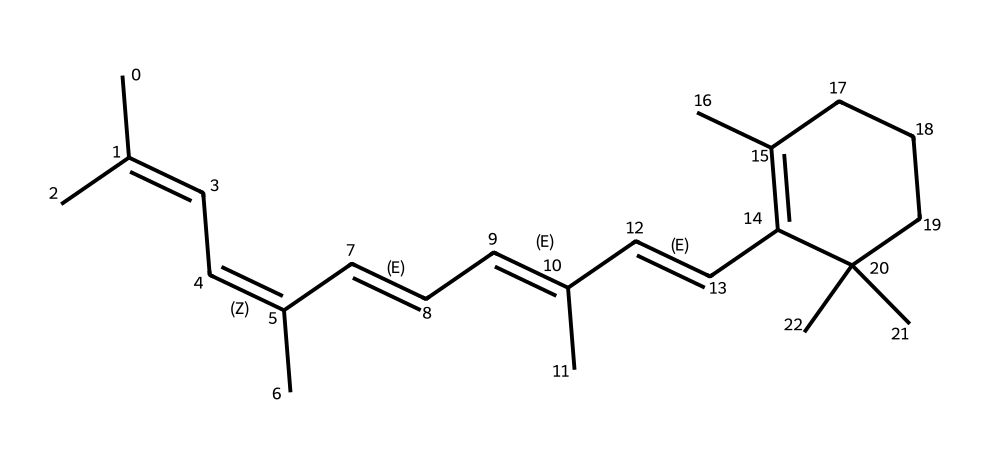how many carbon atoms are in this structure? The chemical structure can be analyzed by counting the carbon atoms in the SMILES representation. Each "C" or "C(" indicates a carbon atom. In this case, there are 20 carbon atoms in total.
Answer: 20 what functional groups are present in retinal? By examining the structure, retinal contains conjugated double bonds (alkene) but does not have any hydroxyl, carboxylic acid, or amine groups. The presence of multiple double bonds is characteristic of aldehydes, as the molecule ends with the -C=O functional group present in its open-chain form. Thus, it is primarily an alkene with an aldehyde functional group.
Answer: alkene, aldehyde is this molecule a geometric isomer? Since retinal contains multiple carbon-carbon double bonds which allow for cis and trans isomerism, it qualifies as a geometric isomer based on the arrangement of its substituent groups around the double bonds.
Answer: yes what is the cis-trans configuration at the retinal's double bonds? In retinal, the double bonds can either be in cis or trans configuration based on the position of hydrogen and carbon substituents. Specifically, the configuration will alternate throughout the molecule, with both cis and trans configurations present due to the varying orientation of substituents around the double bonds.
Answer: mixed how does stage lighting affect the isomerization of retinal? Stage lighting, particularly with different wavelengths of light, can cause isomerization by energizing the electrons in the double bonds of retinal, transitioning between cis and trans configurations. This change facilitates the process of visual pigment response to light, leading to the perception of visual stimuli.
Answer: isomerization 